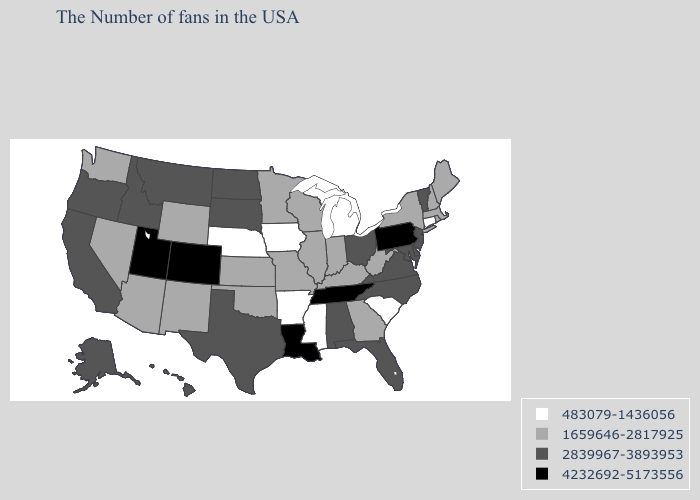Name the states that have a value in the range 2839967-3893953?
Concise answer only. Vermont, New Jersey, Delaware, Maryland, Virginia, North Carolina, Ohio, Florida, Alabama, Texas, South Dakota, North Dakota, Montana, Idaho, California, Oregon, Alaska, Hawaii. Does Virginia have the lowest value in the USA?
Quick response, please. No. Name the states that have a value in the range 2839967-3893953?
Quick response, please. Vermont, New Jersey, Delaware, Maryland, Virginia, North Carolina, Ohio, Florida, Alabama, Texas, South Dakota, North Dakota, Montana, Idaho, California, Oregon, Alaska, Hawaii. Does the map have missing data?
Concise answer only. No. Does Connecticut have the lowest value in the USA?
Concise answer only. Yes. Does Nebraska have a lower value than Michigan?
Keep it brief. No. What is the value of Pennsylvania?
Keep it brief. 4232692-5173556. Among the states that border Texas , which have the highest value?
Be succinct. Louisiana. Does Tennessee have the highest value in the South?
Concise answer only. Yes. Does the first symbol in the legend represent the smallest category?
Short answer required. Yes. Which states have the highest value in the USA?
Answer briefly. Pennsylvania, Tennessee, Louisiana, Colorado, Utah. Among the states that border Idaho , which have the lowest value?
Write a very short answer. Wyoming, Nevada, Washington. Does Michigan have a higher value than Washington?
Answer briefly. No. Does Tennessee have the highest value in the South?
Answer briefly. Yes. How many symbols are there in the legend?
Keep it brief. 4. 